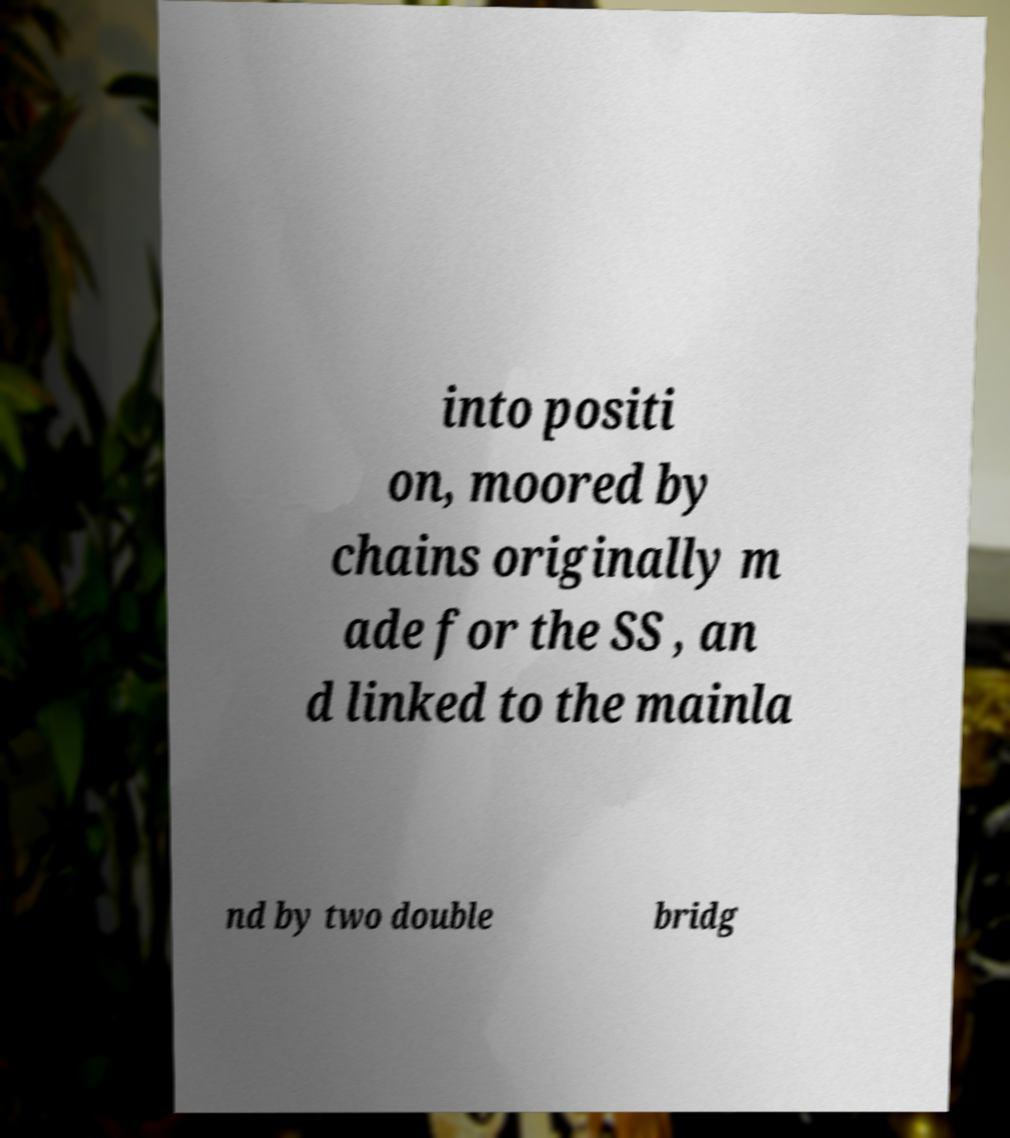Could you extract and type out the text from this image? into positi on, moored by chains originally m ade for the SS , an d linked to the mainla nd by two double bridg 